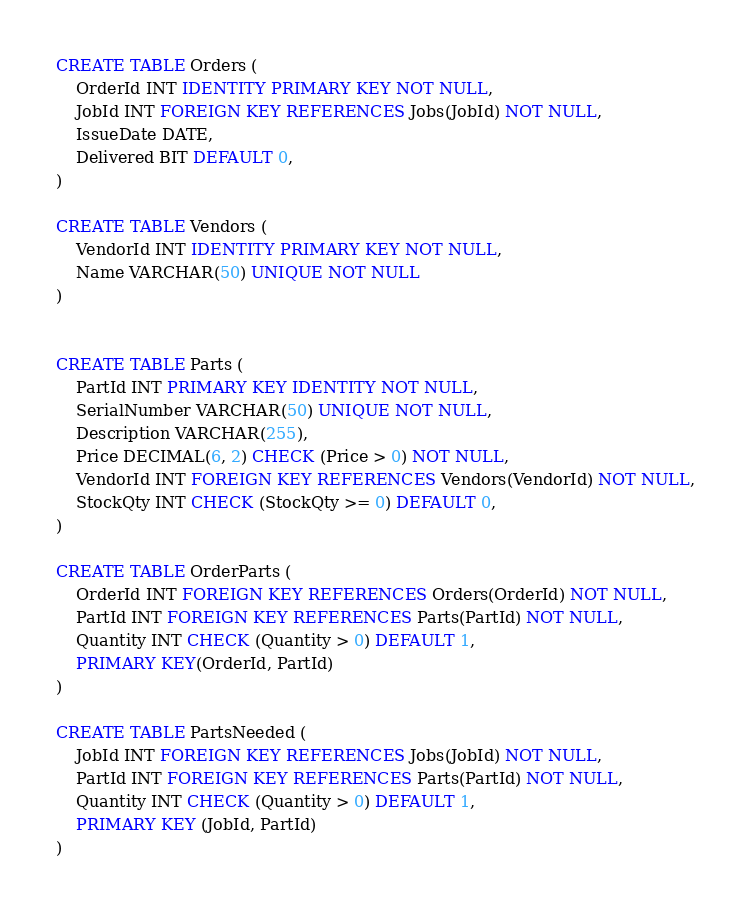<code> <loc_0><loc_0><loc_500><loc_500><_SQL_>CREATE TABLE Orders (
	OrderId INT IDENTITY PRIMARY KEY NOT NULL,
	JobId INT FOREIGN KEY REFERENCES Jobs(JobId) NOT NULL,
	IssueDate DATE,
	Delivered BIT DEFAULT 0,
)

CREATE TABLE Vendors (
	VendorId INT IDENTITY PRIMARY KEY NOT NULL,
	Name VARCHAR(50) UNIQUE NOT NULL
)


CREATE TABLE Parts (
	PartId INT PRIMARY KEY IDENTITY NOT NULL,
	SerialNumber VARCHAR(50) UNIQUE NOT NULL,
	Description VARCHAR(255),
	Price DECIMAL(6, 2) CHECK (Price > 0) NOT NULL,
	VendorId INT FOREIGN KEY REFERENCES Vendors(VendorId) NOT NULL,
	StockQty INT CHECK (StockQty >= 0) DEFAULT 0,
)

CREATE TABLE OrderParts (
	OrderId INT FOREIGN KEY REFERENCES Orders(OrderId) NOT NULL,
	PartId INT FOREIGN KEY REFERENCES Parts(PartId) NOT NULL,
	Quantity INT CHECK (Quantity > 0) DEFAULT 1,
	PRIMARY KEY(OrderId, PartId)
)

CREATE TABLE PartsNeeded (
	JobId INT FOREIGN KEY REFERENCES Jobs(JobId) NOT NULL,
	PartId INT FOREIGN KEY REFERENCES Parts(PartId) NOT NULL,
	Quantity INT CHECK (Quantity > 0) DEFAULT 1,
	PRIMARY KEY (JobId, PartId)
)
</code> 